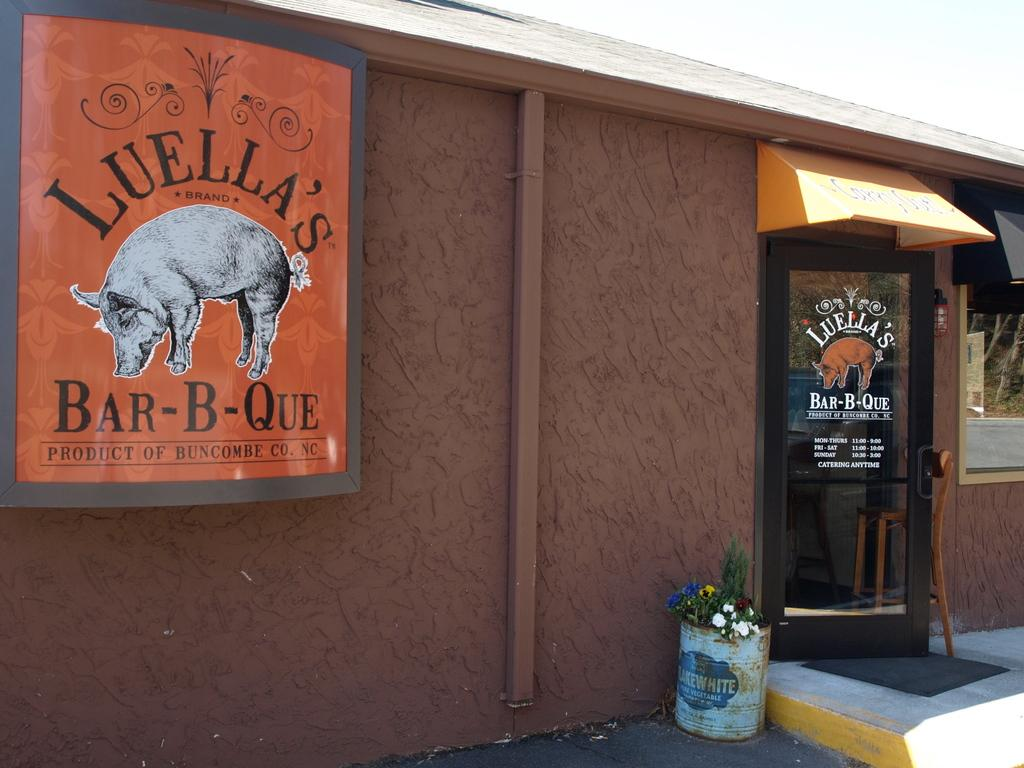What type of structure is shown in the image? The image appears to depict a house. What can be seen attached to the wall in the image? There is a board attached to the wall in the image. Where is the door located in the image? The door is on the right side of the image. What type of vegetation is present at the bottom of the image? Flower plants are present at the bottom of the image. What type of pickle is hanging from the roof in the image? There is no pickle present in the image; it depicts a house with a board, door, and flower plants. 